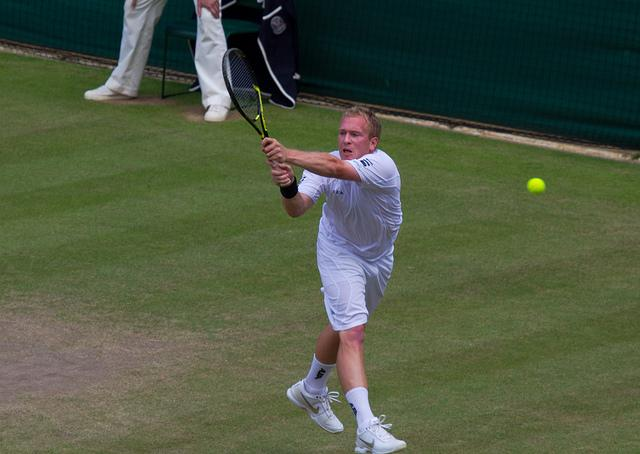What is the player ready to do? hit ball 